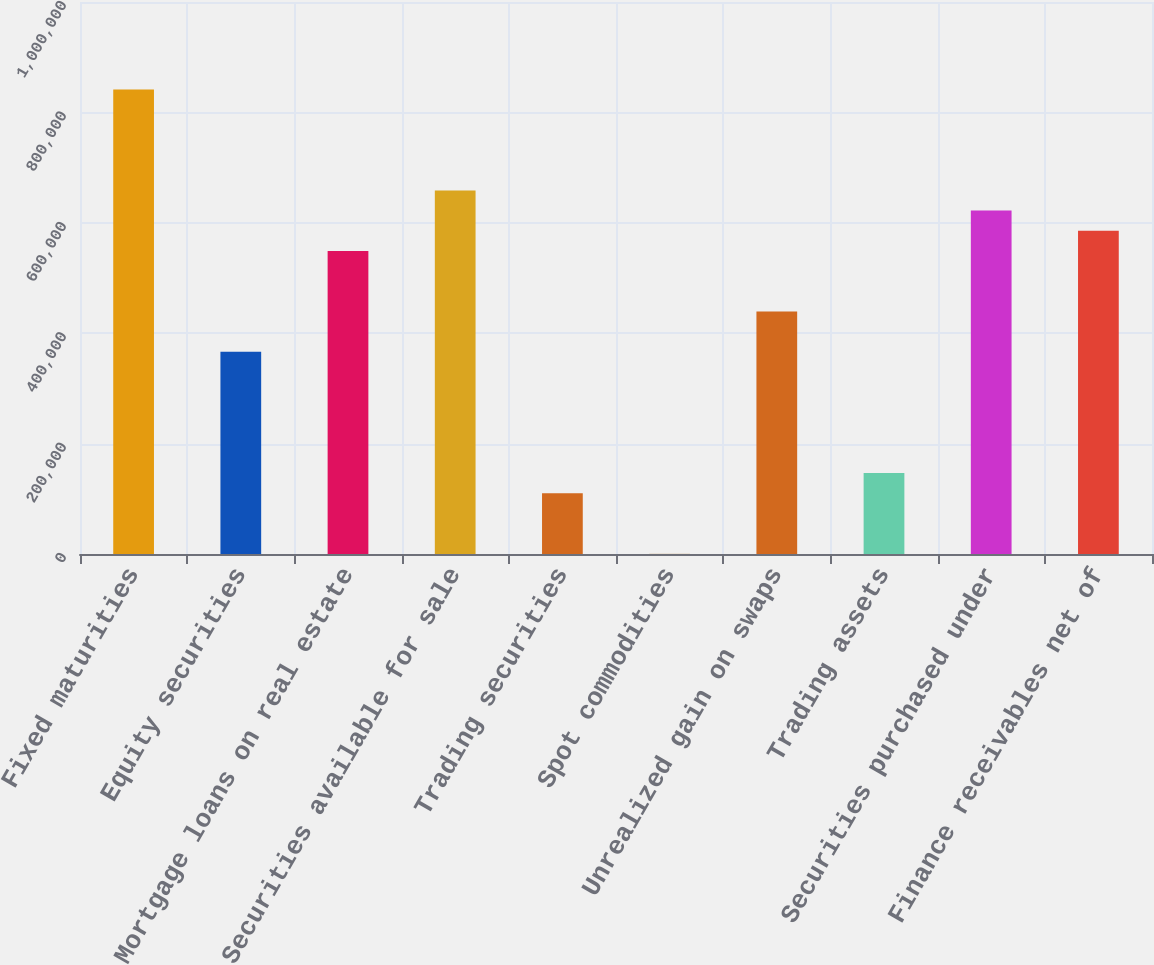<chart> <loc_0><loc_0><loc_500><loc_500><bar_chart><fcel>Fixed maturities<fcel>Equity securities<fcel>Mortgage loans on real estate<fcel>Securities available for sale<fcel>Trading securities<fcel>Spot commodities<fcel>Unrealized gain on swaps<fcel>Trading assets<fcel>Securities purchased under<fcel>Finance receivables net of<nl><fcel>841506<fcel>366174<fcel>548994<fcel>658686<fcel>110226<fcel>534<fcel>439302<fcel>146790<fcel>622122<fcel>585558<nl></chart> 